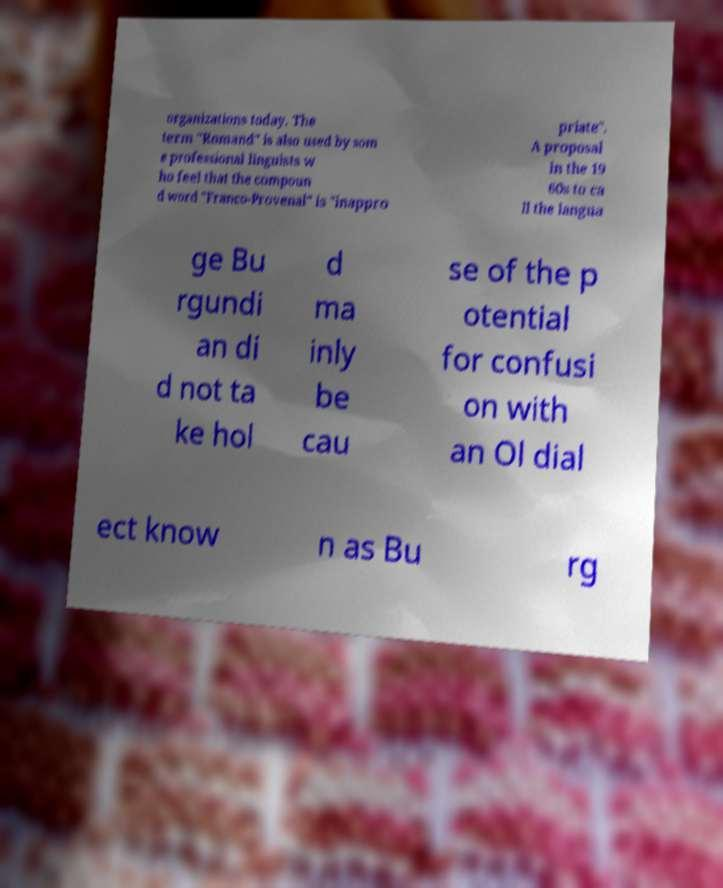Could you extract and type out the text from this image? organizations today. The term "Romand" is also used by som e professional linguists w ho feel that the compoun d word "Franco-Provenal" is "inappro priate". A proposal in the 19 60s to ca ll the langua ge Bu rgundi an di d not ta ke hol d ma inly be cau se of the p otential for confusi on with an Ol dial ect know n as Bu rg 